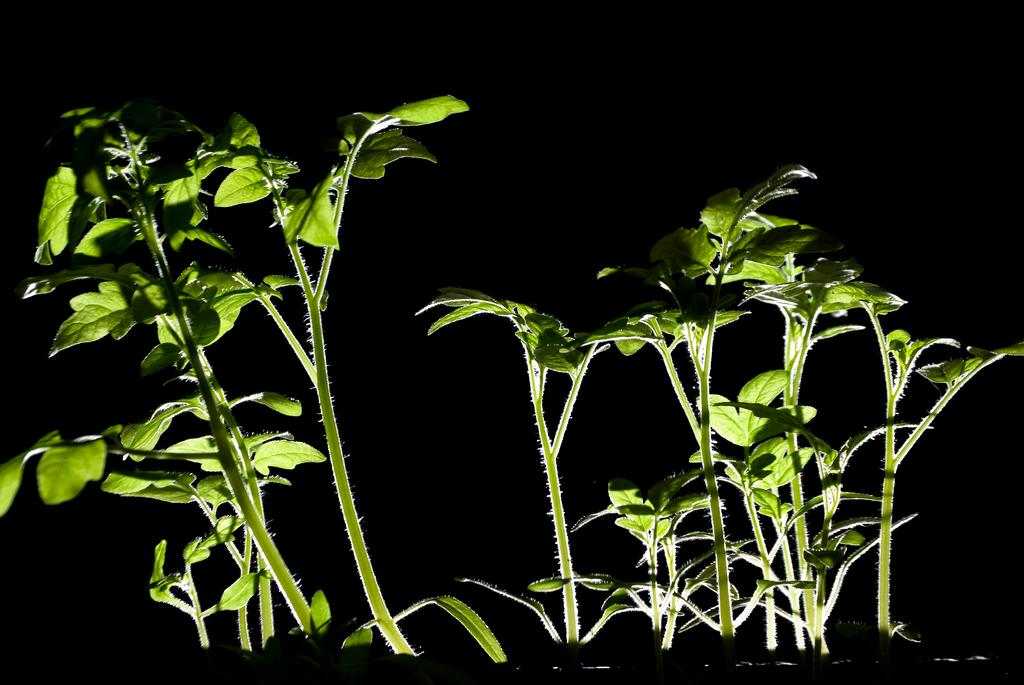What type of living organisms can be seen in the image? Plants can be seen in the image. What type of channel is visible in the image? There is no channel present in the image; it only features plants. Is there a carpenter working on any wooden structures in the image? There is no carpenter or wooden structures present in the image; it only features plants. 